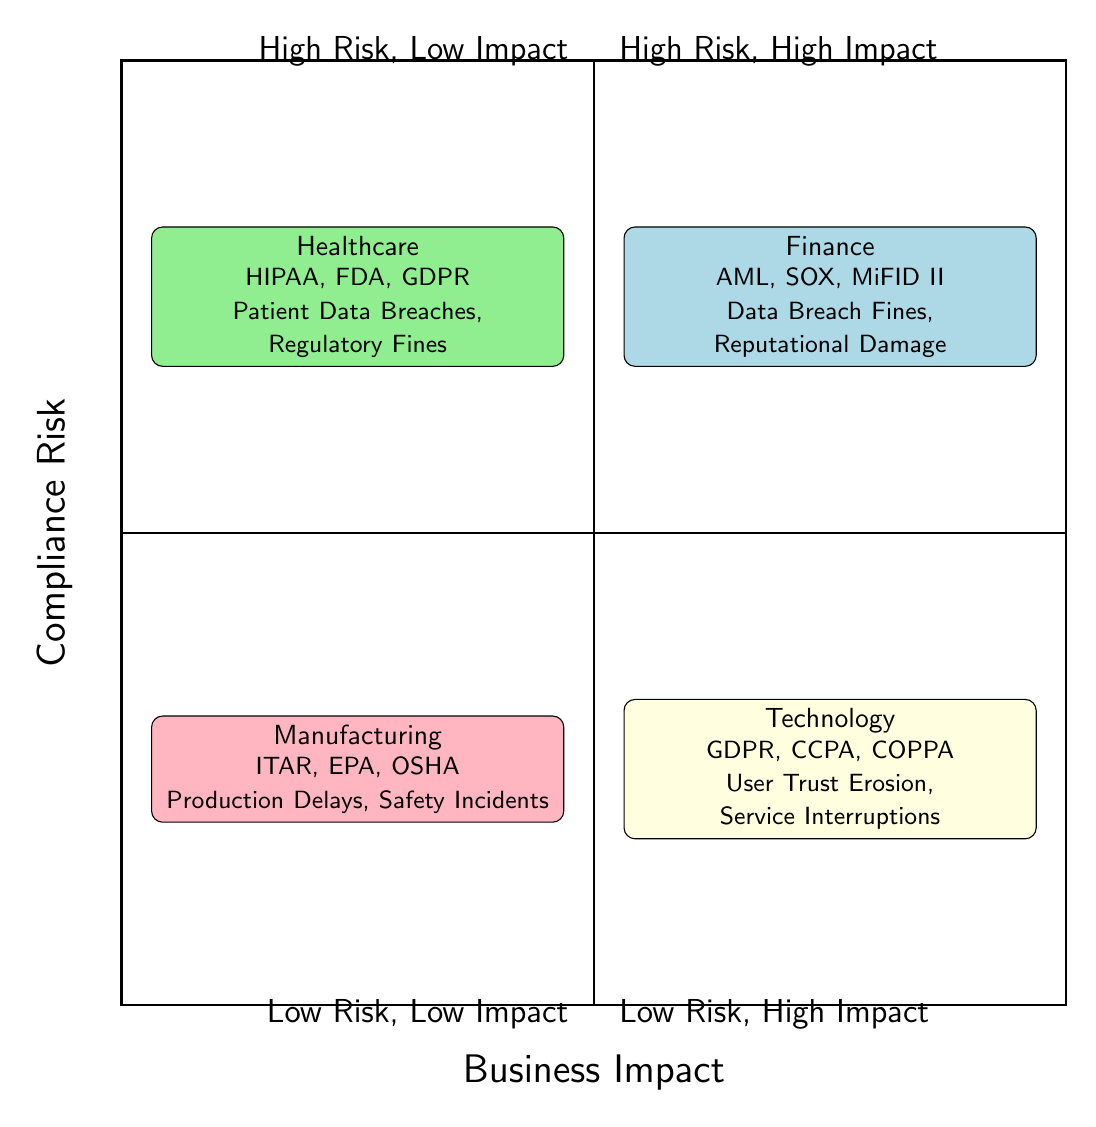What industries are represented in the chart? The chart includes Finance, Healthcare, Technology, and Manufacturing as indicated in the data shown at the four corners of the quadrants.
Answer: Finance, Healthcare, Technology, Manufacturing Which industry is associated with the compliance risk of HIPAA? HIPAA is listed under the Healthcare compliance risks in the top left quadrant, which is where Healthcare is positioned in the chart.
Answer: Healthcare What are the compliance risks listed for the Finance industry? The Finance industry has three compliance risks: Anti-Money Laundering (AML) Regulations, Sarbanes-Oxley Act (SOX) Compliance, and Markets in Financial Instruments Directive (MiFID II) as observed in the node for Finance.
Answer: Anti-Money Laundering (AML) Regulations, Sarbanes-Oxley Act (SOX) Compliance, Markets in Financial Instruments Directive (MiFID II) Which industry is at the intersection of High Compliance Risk and Low Business Impact? Looking at the quadrants, the Technology industry is placed in the lower right quadrant (Low Risk, High Impact) but also relates to compliance risks affecting user trust, which connects to lower business impact scenarios.
Answer: Technology What is the business impact associated with the compliance risks in the Manufacturing industry? The Manufacturing industry lists business impacts such as Production Delays, Environmental Cleanup Costs, and Worker Safety Incidents, which reflect potential negative outcomes of compliance risks specific to manufacturing regulations.
Answer: Production Delays, Environmental Cleanup Costs, Worker Safety Incidents Which quadrant represents High Compliance Risk and High Business Impact? The top left quadrant, labeled as High Risk, High Impact, contains the Healthcare industry. This is indicated by the placement of the Healthcare node which details significant compliance risks and potential business impacts.
Answer: High Risk, High Impact How many compliance risks are associated with the Technology industry? There are three compliance risks associated with the Technology industry, which includes GDPR, CCPA, and COPPA, as represented in the quadrants of the chart.
Answer: Three What is the primary compliance risk for the Manufacturing industry? The Manufacturing industry has International Traffic in Arms Regulations (ITAR), indicated in the quadrant, as one of its primary compliance risks related to their operational regulations.
Answer: International Traffic in Arms Regulations (ITAR) What business impact is related to data breach fines in the Finance industry? The Finance industry specifically lists Data Breach Fines as a business impact under the potential outcomes of compliance risks, highlighting the direct financial consequences of non-compliance.
Answer: Data Breach Fines 